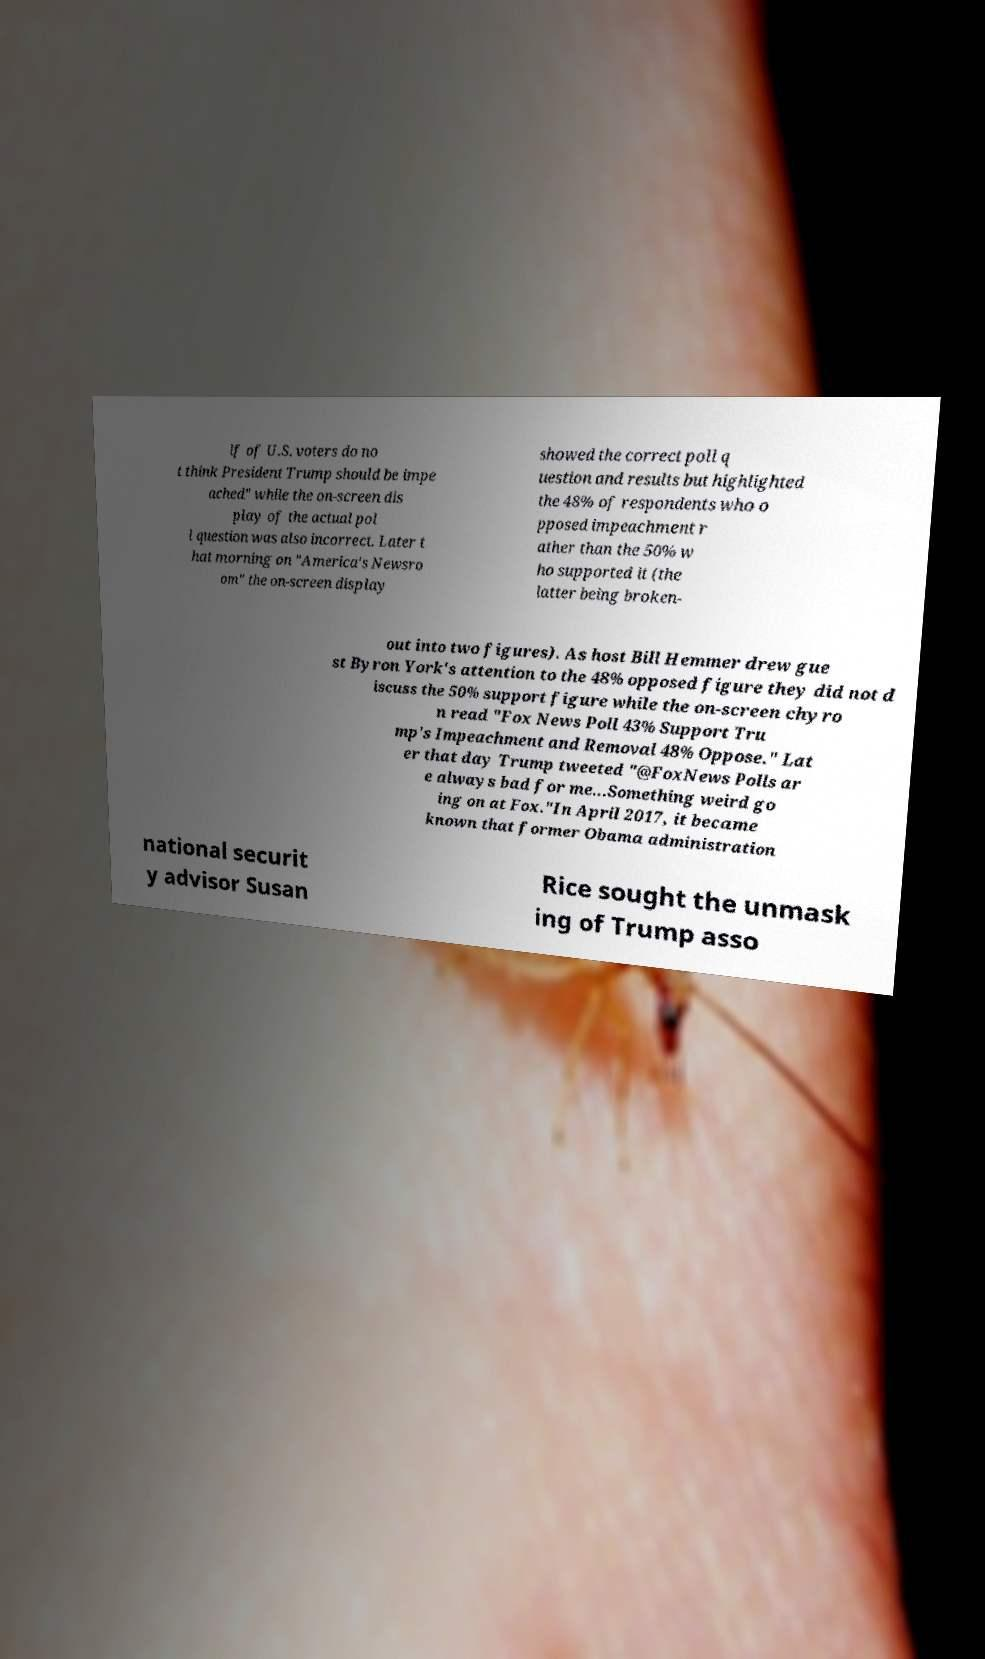Please identify and transcribe the text found in this image. lf of U.S. voters do no t think President Trump should be impe ached" while the on-screen dis play of the actual pol l question was also incorrect. Later t hat morning on "America's Newsro om" the on-screen display showed the correct poll q uestion and results but highlighted the 48% of respondents who o pposed impeachment r ather than the 50% w ho supported it (the latter being broken- out into two figures). As host Bill Hemmer drew gue st Byron York's attention to the 48% opposed figure they did not d iscuss the 50% support figure while the on-screen chyro n read "Fox News Poll 43% Support Tru mp's Impeachment and Removal 48% Oppose." Lat er that day Trump tweeted "@FoxNews Polls ar e always bad for me...Something weird go ing on at Fox."In April 2017, it became known that former Obama administration national securit y advisor Susan Rice sought the unmask ing of Trump asso 